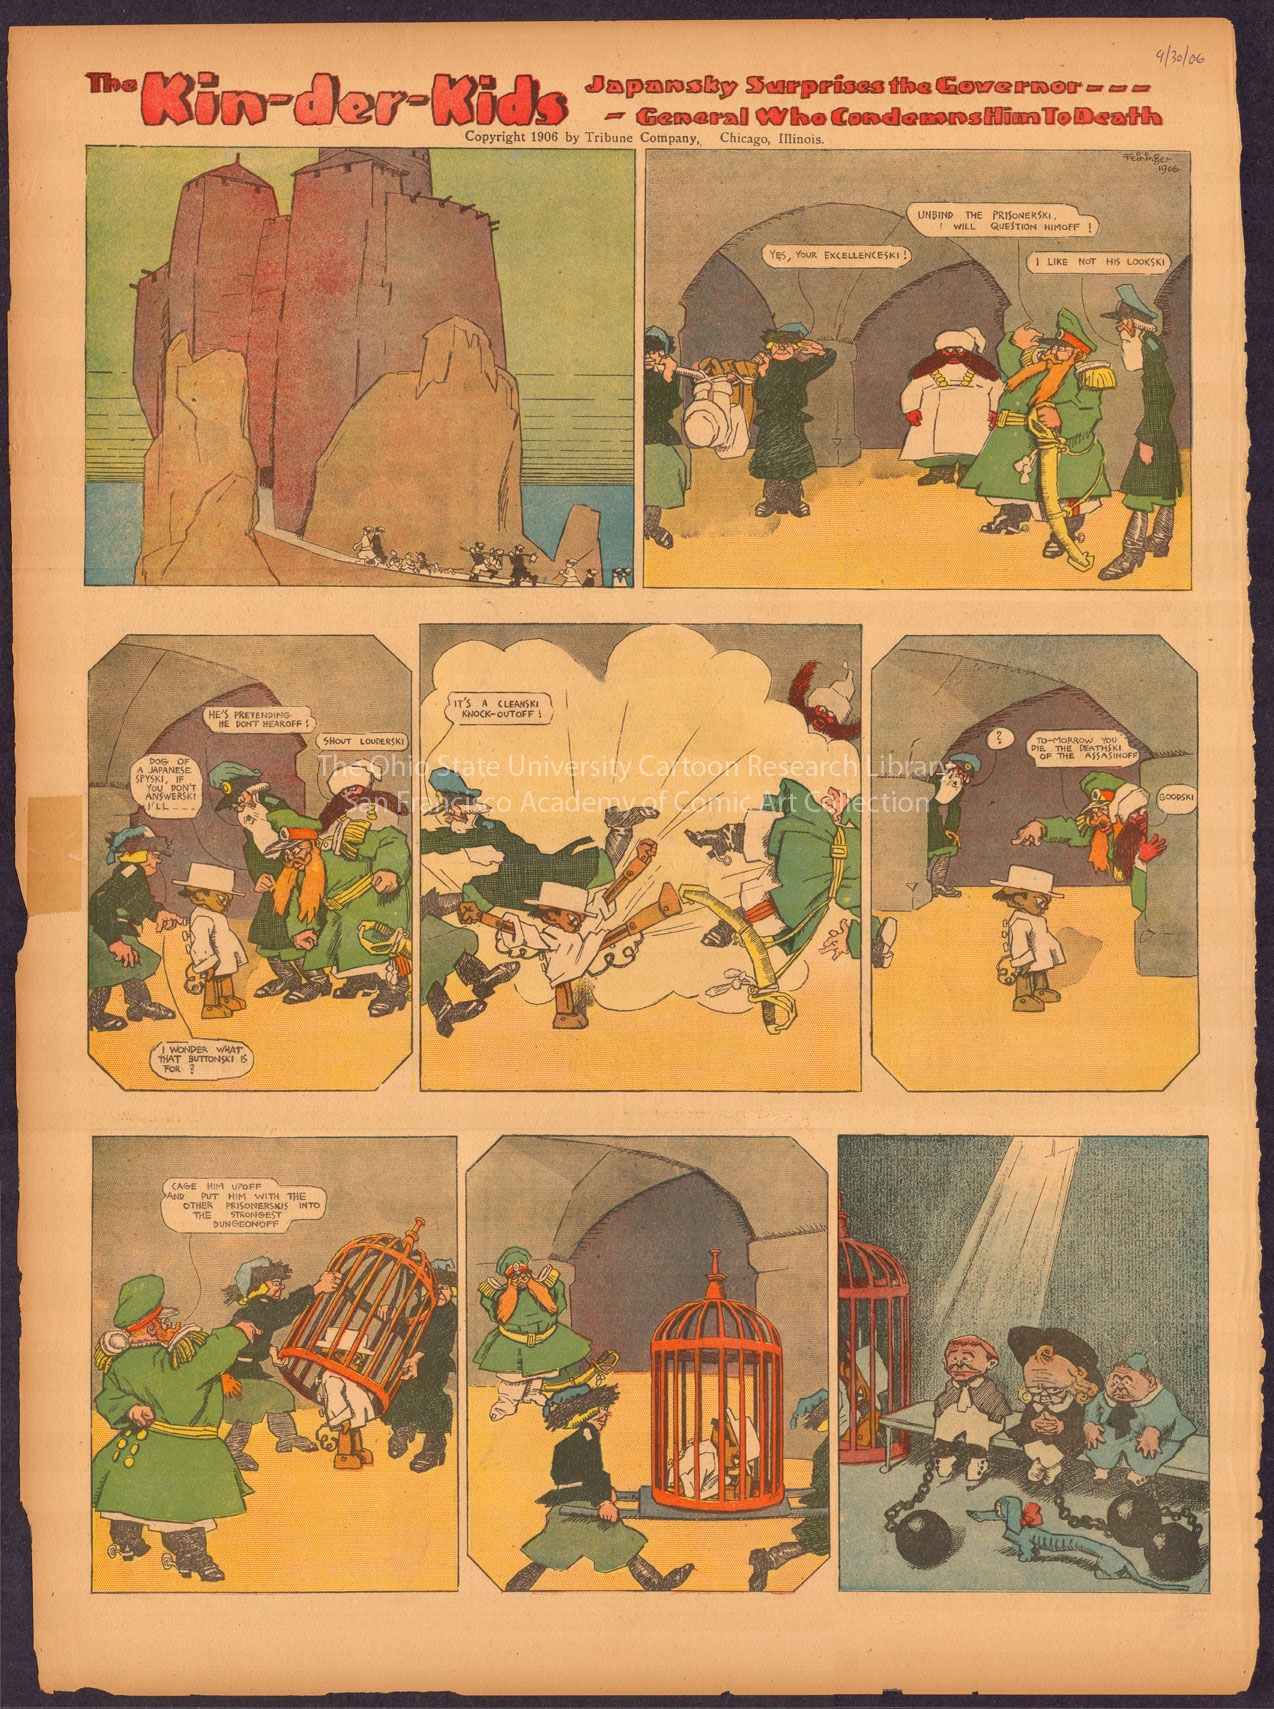Can you tell me about the historical context of this comic strip? 'The Kin-der-Kids' comic strip was introduced in the early 20th century, a time when newspapers were a primary source of entertainment. Its creator, Lyonel Feininger, was an American-German artist who later became a prominent figure in the German Expressionist movement. The early 1900s was a period of experimentation in mass media and print technology, allowing for the inclusion of colorful Sunday comic supplements. Comics like these often provided light social commentary and were a playful reflection of the attitudes and concerns of the time, appealing to both an adult and a younger readership. 